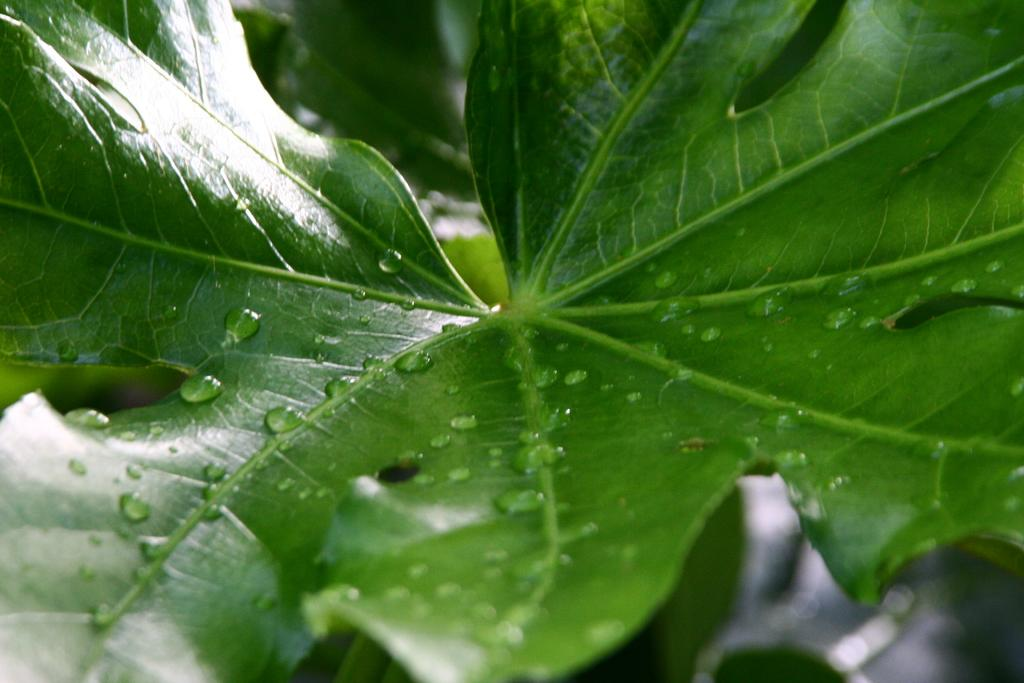What is the main subject of the image? The main subject of the image is a leaf. Can you describe the level of detail in the image? The image is a zoomed in picture of the leaf. What type of pain is the leaf experiencing in the image? The leaf is not capable of experiencing pain, as it is an inanimate object. What point is the leaf trying to make in the image? The leaf is not capable of making a point, as it is an inanimate object. 